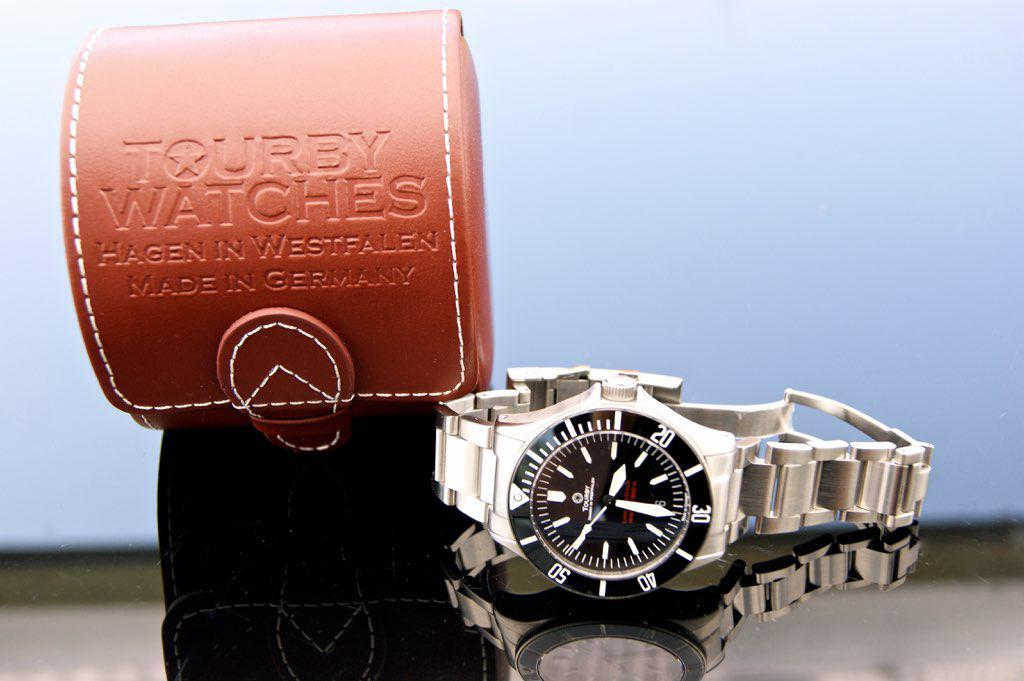<image>
Relay a brief, clear account of the picture shown. A Tourby watch that was made in Germany. 